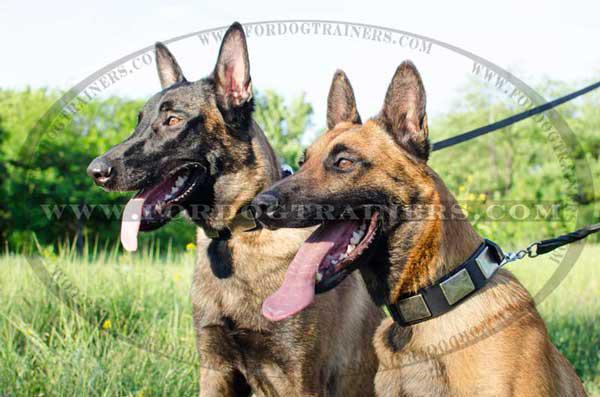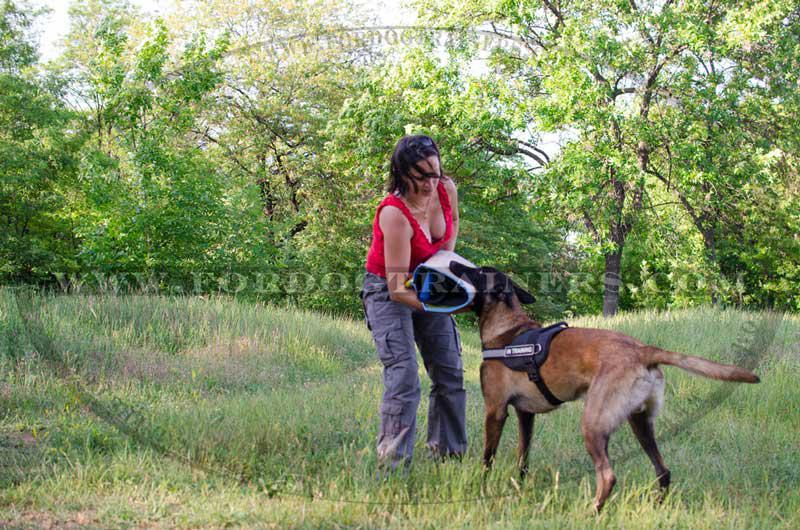The first image is the image on the left, the second image is the image on the right. Evaluate the accuracy of this statement regarding the images: "One image shows two adult german shepherd dogs posed similarly side-by-side.". Is it true? Answer yes or no. Yes. The first image is the image on the left, the second image is the image on the right. Examine the images to the left and right. Is the description "At least one dog is standing near a fence in the image on the left." accurate? Answer yes or no. No. 